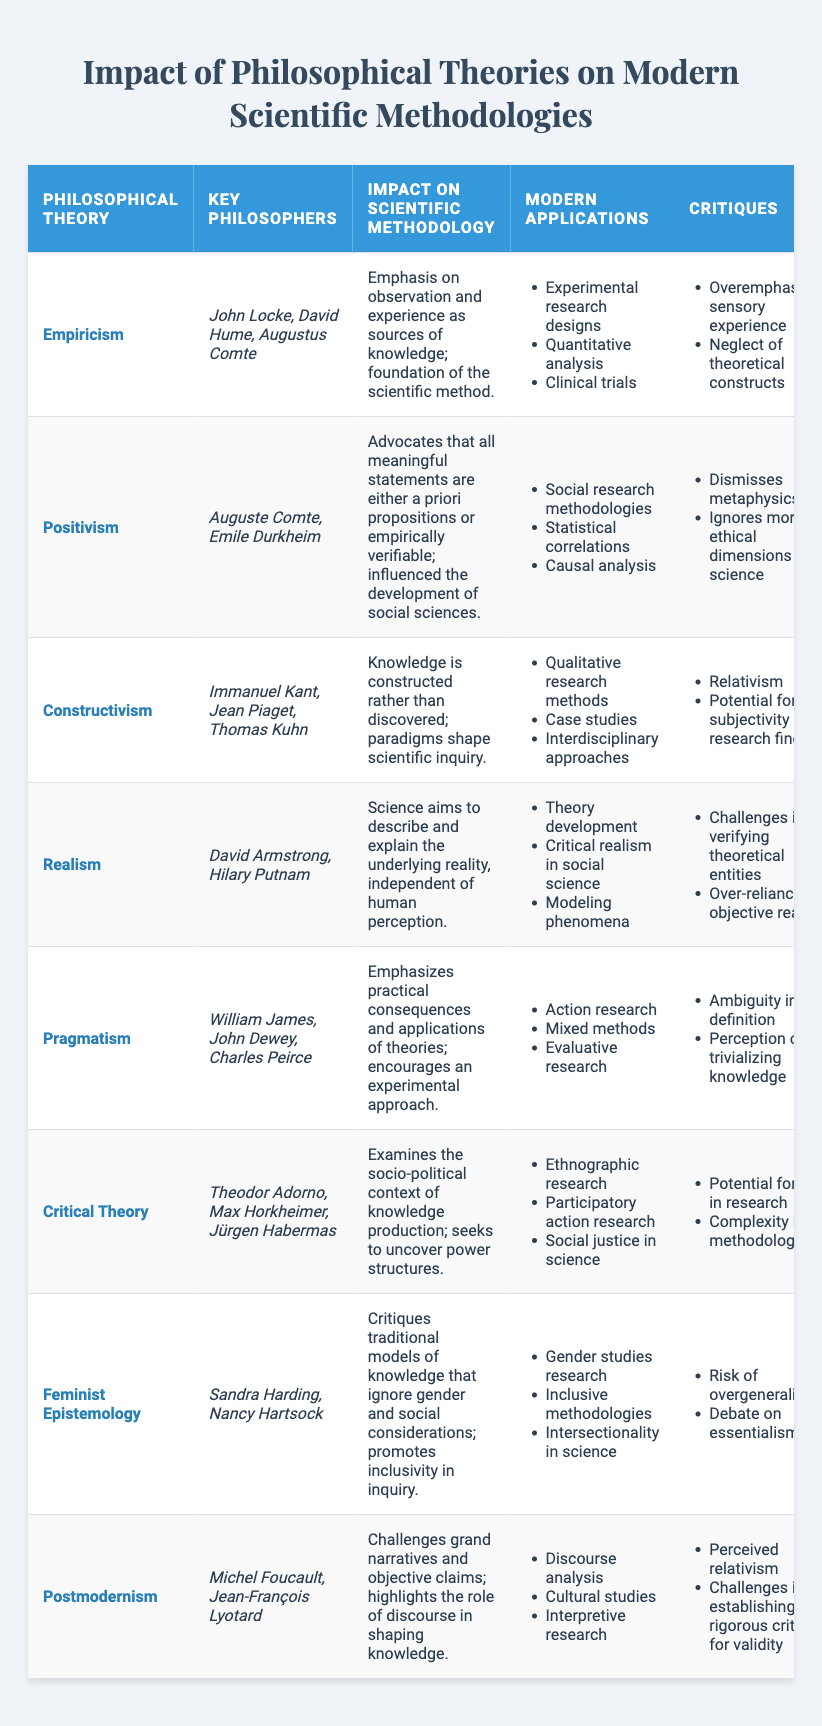What philosophical theory emphasizes the role of observation and experience? The table indicates that "Empiricism" emphasizes observation and experience as sources of knowledge, which is stated in the corresponding impact description.
Answer: Empiricism Which key philosophers are associated with Positivism? According to the table, the key philosophers associated with Positivism are Auguste Comte and Emile Durkheim, as listed under that theory.
Answer: Auguste Comte, Emile Durkheim What are two modern applications of Constructivism? The table lists three modern applications under Constructivism, which include qualitative research methods and case studies. These can be easily retrieved from the relevant section of the table.
Answer: Qualitative research methods, case studies True or False: Realism posits that scientific aims are dependent on human perception. The table's impact statement on Realism clarifies that it aims to describe and explain an underlying reality independent of human perception. Thus, the statement is false.
Answer: False Which philosophical theory has critiques related to "potential for bias in research"? Looking into the critiques column, the phrase "potential for bias in research" is specifically associated with "Critical Theory," which is listed in the table.
Answer: Critical Theory What is the common critique of Feminist Epistemology? The table indicates that one common critique of Feminist Epistemology is the "risk of overgeneralization," among other critiques listed for that theory.
Answer: Risk of overgeneralization Compare the modern applications of Positivism and Pragmatism: how many total applications do they share? The table lists three applications each for Positivism and Pragmatism. The common applications need to be identified separately, which are not listed explicitly; however, it requires individual analysis of both sections. Upon review, they do not share any applications, resulting in a total of zero.
Answer: 0 Which philosophical theory critiques traditional models of knowledge? Provide the modern application related to this critique. The table reveals that "Feminist Epistemology" critiques traditional models of knowledge, and one of its modern applications related to this is "gender studies research."
Answer: Feminist Epistemology; gender studies research What is the impact of Critical Theory on scientific methodologies? The table notes that Critical Theory concerns the socio-political context of knowledge production and seeks to uncover power structures; this impact specifically shapes scientific inquiry in a socio-political light.
Answer: Examines the socio-political context of knowledge production Which philosophical theory highlights the role of discourse and challenges grand narratives? According to the table, "Postmodernism" is the philosophical theory that challenges grand narratives and emphasizes the role of discourse in shaping knowledge.
Answer: Postmodernism 